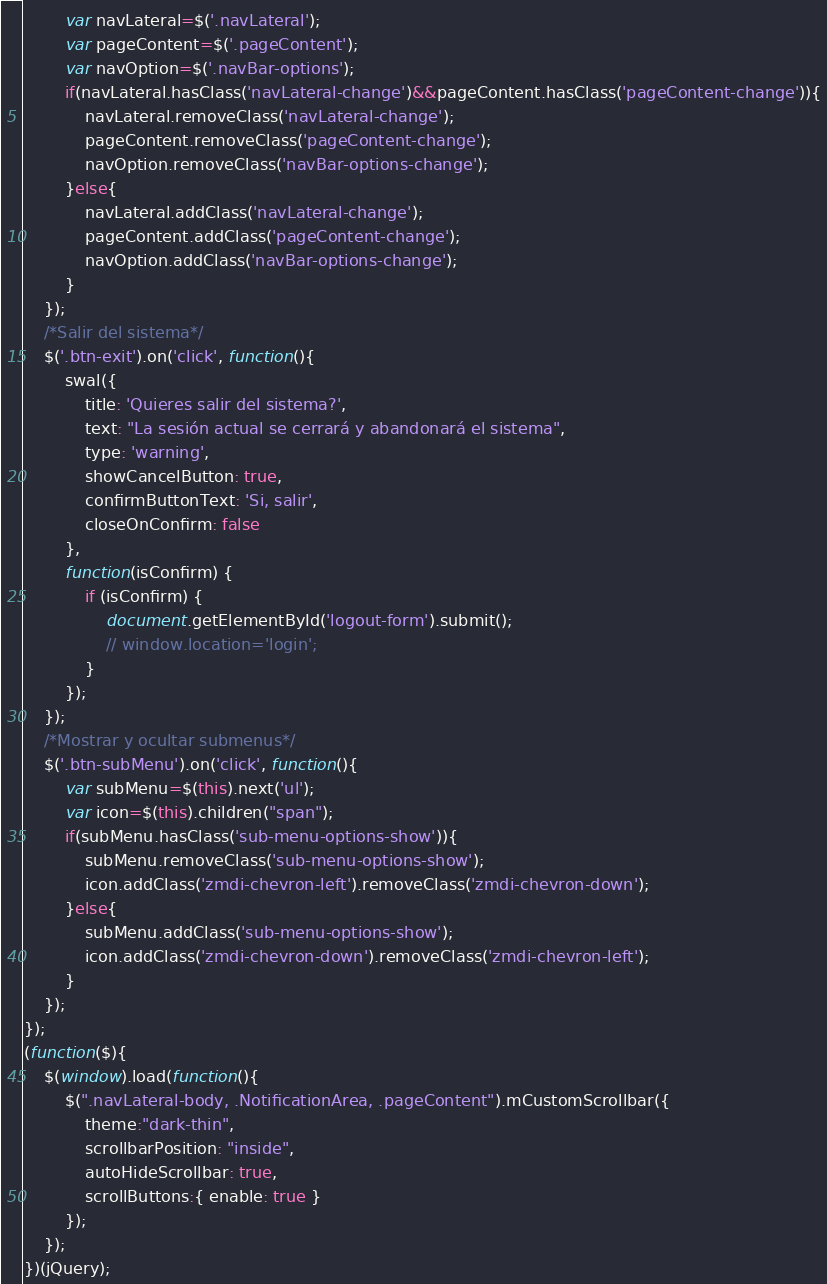Convert code to text. <code><loc_0><loc_0><loc_500><loc_500><_JavaScript_>    	var navLateral=$('.navLateral');
    	var pageContent=$('.pageContent');
    	var navOption=$('.navBar-options');
    	if(navLateral.hasClass('navLateral-change')&&pageContent.hasClass('pageContent-change')){
    		navLateral.removeClass('navLateral-change');
    		pageContent.removeClass('pageContent-change');
    		navOption.removeClass('navBar-options-change');
    	}else{
    		navLateral.addClass('navLateral-change');
    		pageContent.addClass('pageContent-change');
    		navOption.addClass('navBar-options-change');
    	}
    });
    /*Salir del sistema*/
    $('.btn-exit').on('click', function(){
    	swal({
		  	title: 'Quieres salir del sistema?',
		 	text: "La sesión actual se cerrará y abandonará el sistema",
		  	type: 'warning',
		  	showCancelButton: true,
		  	confirmButtonText: 'Si, salir',
		  	closeOnConfirm: false
		},
		function(isConfirm) {
		  	if (isConfirm) {                
                document.getElementById('logout-form').submit();
		    	// window.location='login'; 
		  	}
		});
    });
    /*Mostrar y ocultar submenus*/
    $('.btn-subMenu').on('click', function(){
    	var subMenu=$(this).next('ul');
    	var icon=$(this).children("span");
    	if(subMenu.hasClass('sub-menu-options-show')){
    		subMenu.removeClass('sub-menu-options-show');
    		icon.addClass('zmdi-chevron-left').removeClass('zmdi-chevron-down');
    	}else{
    		subMenu.addClass('sub-menu-options-show');
    		icon.addClass('zmdi-chevron-down').removeClass('zmdi-chevron-left');
    	}
    });
});
(function($){
    $(window).load(function(){
        $(".navLateral-body, .NotificationArea, .pageContent").mCustomScrollbar({
            theme:"dark-thin",
            scrollbarPosition: "inside",
            autoHideScrollbar: true,
            scrollButtons:{ enable: true }
        });
    });
})(jQuery);</code> 